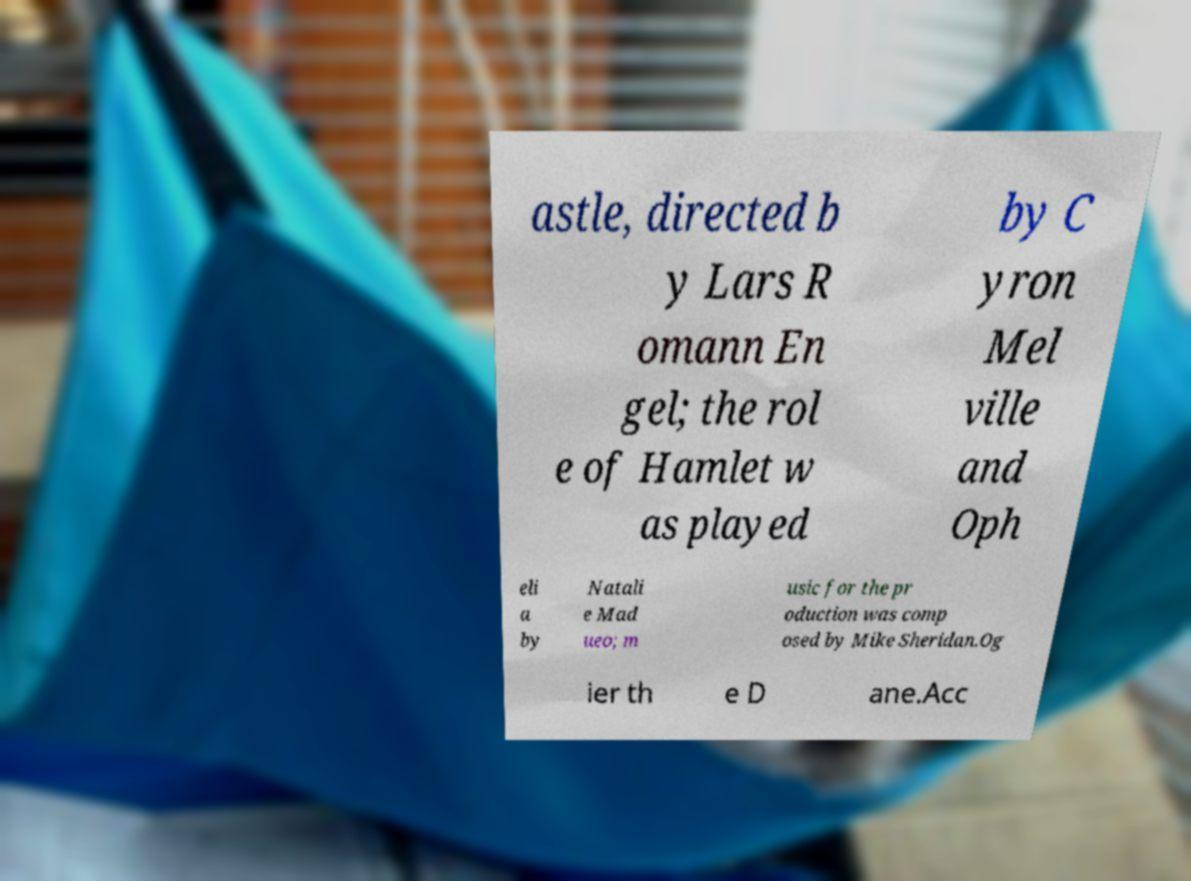There's text embedded in this image that I need extracted. Can you transcribe it verbatim? astle, directed b y Lars R omann En gel; the rol e of Hamlet w as played by C yron Mel ville and Oph eli a by Natali e Mad ueo; m usic for the pr oduction was comp osed by Mike Sheridan.Og ier th e D ane.Acc 